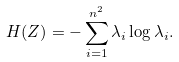Convert formula to latex. <formula><loc_0><loc_0><loc_500><loc_500>H ( Z ) = - \sum _ { i = 1 } ^ { n ^ { 2 } } \lambda _ { i } \log \lambda _ { i } .</formula> 